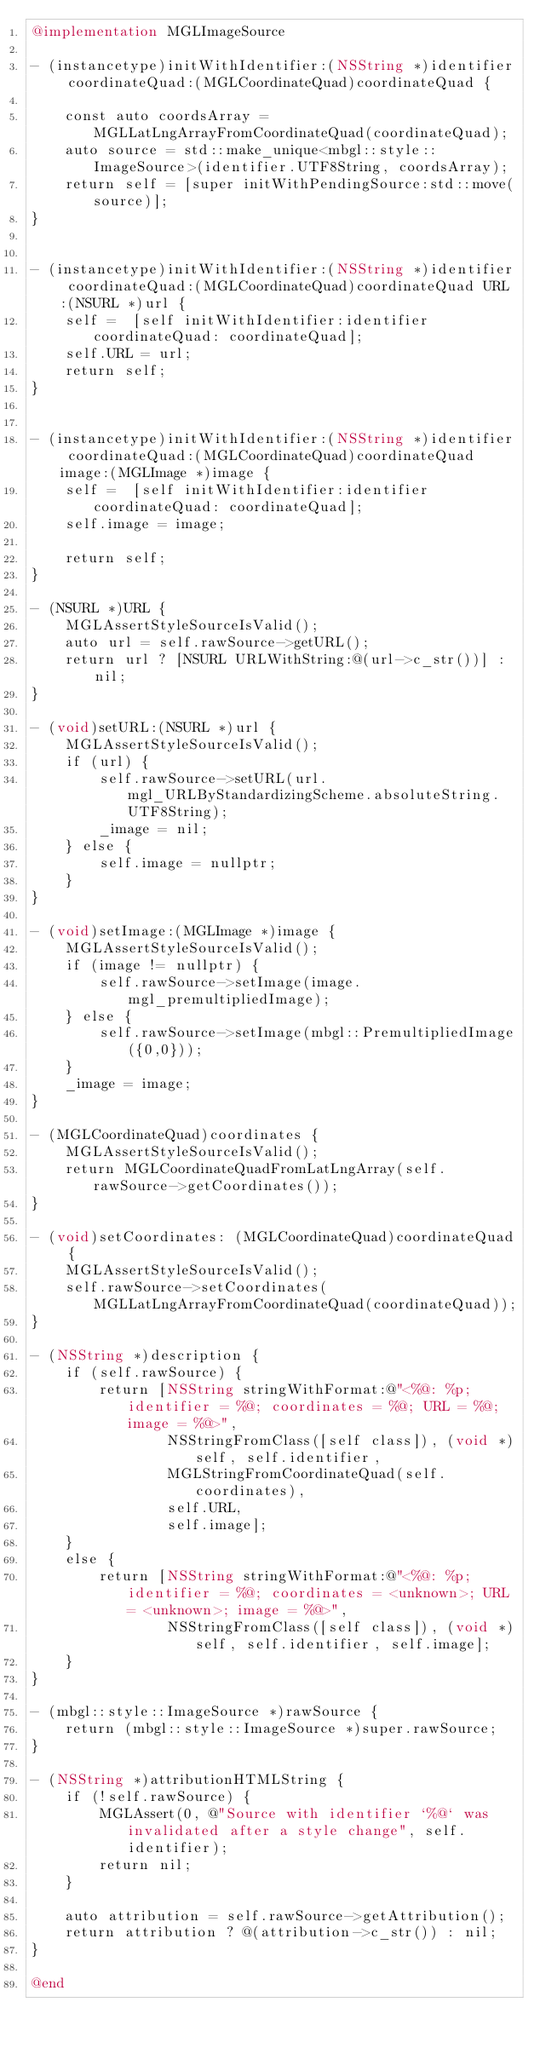<code> <loc_0><loc_0><loc_500><loc_500><_ObjectiveC_>@implementation MGLImageSource

- (instancetype)initWithIdentifier:(NSString *)identifier coordinateQuad:(MGLCoordinateQuad)coordinateQuad {

    const auto coordsArray = MGLLatLngArrayFromCoordinateQuad(coordinateQuad);
    auto source = std::make_unique<mbgl::style::ImageSource>(identifier.UTF8String, coordsArray);
    return self = [super initWithPendingSource:std::move(source)];
}


- (instancetype)initWithIdentifier:(NSString *)identifier coordinateQuad:(MGLCoordinateQuad)coordinateQuad URL:(NSURL *)url {
    self =  [self initWithIdentifier:identifier coordinateQuad: coordinateQuad];
    self.URL = url;
    return self;
}


- (instancetype)initWithIdentifier:(NSString *)identifier coordinateQuad:(MGLCoordinateQuad)coordinateQuad image:(MGLImage *)image {
    self =  [self initWithIdentifier:identifier coordinateQuad: coordinateQuad];
    self.image = image;

    return self;
}

- (NSURL *)URL {
    MGLAssertStyleSourceIsValid();
    auto url = self.rawSource->getURL();
    return url ? [NSURL URLWithString:@(url->c_str())] : nil;
}

- (void)setURL:(NSURL *)url {
    MGLAssertStyleSourceIsValid();
    if (url) {
        self.rawSource->setURL(url.mgl_URLByStandardizingScheme.absoluteString.UTF8String);
        _image = nil;
    } else {
        self.image = nullptr;
    }
}

- (void)setImage:(MGLImage *)image {
    MGLAssertStyleSourceIsValid();
    if (image != nullptr) {
        self.rawSource->setImage(image.mgl_premultipliedImage);
    } else {
        self.rawSource->setImage(mbgl::PremultipliedImage({0,0}));
    }
    _image = image;
}

- (MGLCoordinateQuad)coordinates {
    MGLAssertStyleSourceIsValid();
    return MGLCoordinateQuadFromLatLngArray(self.rawSource->getCoordinates());
}

- (void)setCoordinates: (MGLCoordinateQuad)coordinateQuad {
    MGLAssertStyleSourceIsValid();
    self.rawSource->setCoordinates(MGLLatLngArrayFromCoordinateQuad(coordinateQuad));
}

- (NSString *)description {
    if (self.rawSource) {
        return [NSString stringWithFormat:@"<%@: %p; identifier = %@; coordinates = %@; URL = %@; image = %@>",
                NSStringFromClass([self class]), (void *)self, self.identifier,
                MGLStringFromCoordinateQuad(self.coordinates),
                self.URL,
                self.image];
    }
    else {
        return [NSString stringWithFormat:@"<%@: %p; identifier = %@; coordinates = <unknown>; URL = <unknown>; image = %@>",
                NSStringFromClass([self class]), (void *)self, self.identifier, self.image];
    }
}

- (mbgl::style::ImageSource *)rawSource {
    return (mbgl::style::ImageSource *)super.rawSource;
}

- (NSString *)attributionHTMLString {
    if (!self.rawSource) {
        MGLAssert(0, @"Source with identifier `%@` was invalidated after a style change", self.identifier);
        return nil;
    }

    auto attribution = self.rawSource->getAttribution();
    return attribution ? @(attribution->c_str()) : nil;
}

@end
</code> 